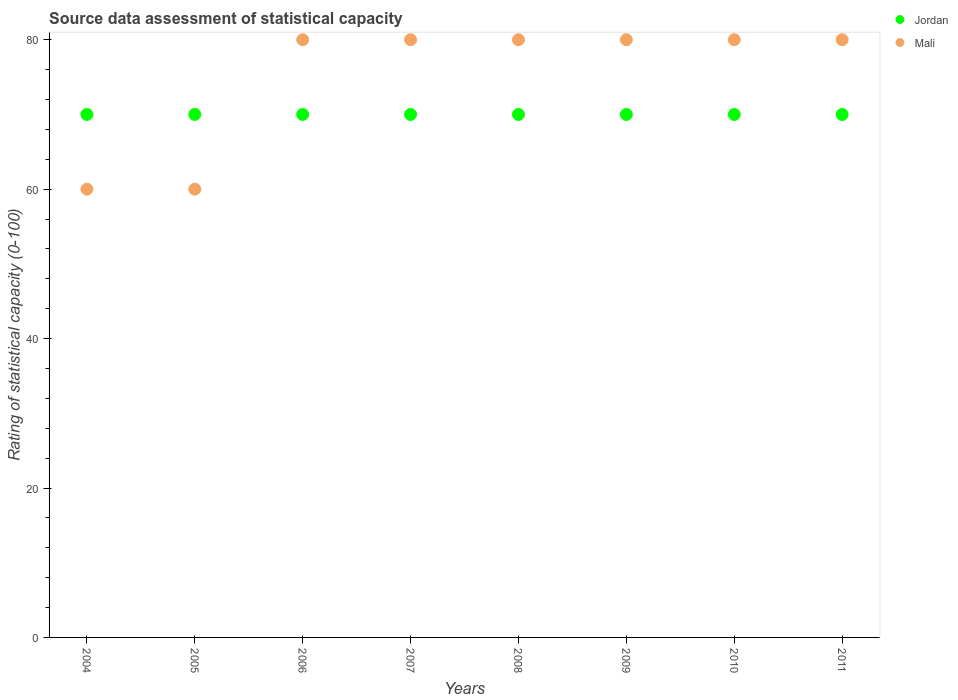What is the rating of statistical capacity in Mali in 2006?
Offer a terse response. 80. Across all years, what is the maximum rating of statistical capacity in Mali?
Your answer should be very brief. 80. Across all years, what is the minimum rating of statistical capacity in Jordan?
Make the answer very short. 70. What is the total rating of statistical capacity in Mali in the graph?
Your answer should be compact. 600. What is the difference between the rating of statistical capacity in Jordan in 2008 and the rating of statistical capacity in Mali in 2007?
Provide a short and direct response. -10. In the year 2005, what is the difference between the rating of statistical capacity in Jordan and rating of statistical capacity in Mali?
Keep it short and to the point. 10. In how many years, is the rating of statistical capacity in Jordan greater than 28?
Ensure brevity in your answer.  8. What is the ratio of the rating of statistical capacity in Jordan in 2006 to that in 2007?
Ensure brevity in your answer.  1. Is the rating of statistical capacity in Mali in 2010 less than that in 2011?
Provide a succinct answer. No. Is the difference between the rating of statistical capacity in Jordan in 2006 and 2009 greater than the difference between the rating of statistical capacity in Mali in 2006 and 2009?
Offer a very short reply. No. What is the difference between the highest and the lowest rating of statistical capacity in Mali?
Provide a short and direct response. 20. Is the sum of the rating of statistical capacity in Mali in 2007 and 2009 greater than the maximum rating of statistical capacity in Jordan across all years?
Give a very brief answer. Yes. What is the title of the graph?
Provide a short and direct response. Source data assessment of statistical capacity. What is the label or title of the Y-axis?
Give a very brief answer. Rating of statistical capacity (0-100). What is the Rating of statistical capacity (0-100) in Mali in 2004?
Offer a terse response. 60. What is the Rating of statistical capacity (0-100) in Jordan in 2006?
Your answer should be very brief. 70. What is the Rating of statistical capacity (0-100) in Mali in 2007?
Provide a short and direct response. 80. What is the Rating of statistical capacity (0-100) in Jordan in 2008?
Provide a succinct answer. 70. What is the Rating of statistical capacity (0-100) in Mali in 2008?
Keep it short and to the point. 80. What is the Rating of statistical capacity (0-100) of Mali in 2009?
Ensure brevity in your answer.  80. Across all years, what is the maximum Rating of statistical capacity (0-100) of Jordan?
Provide a short and direct response. 70. What is the total Rating of statistical capacity (0-100) of Jordan in the graph?
Provide a succinct answer. 560. What is the total Rating of statistical capacity (0-100) in Mali in the graph?
Ensure brevity in your answer.  600. What is the difference between the Rating of statistical capacity (0-100) in Jordan in 2004 and that in 2005?
Ensure brevity in your answer.  0. What is the difference between the Rating of statistical capacity (0-100) of Jordan in 2004 and that in 2006?
Provide a succinct answer. 0. What is the difference between the Rating of statistical capacity (0-100) in Mali in 2004 and that in 2007?
Provide a short and direct response. -20. What is the difference between the Rating of statistical capacity (0-100) in Jordan in 2004 and that in 2008?
Ensure brevity in your answer.  0. What is the difference between the Rating of statistical capacity (0-100) in Mali in 2004 and that in 2008?
Provide a short and direct response. -20. What is the difference between the Rating of statistical capacity (0-100) of Jordan in 2004 and that in 2011?
Make the answer very short. 0. What is the difference between the Rating of statistical capacity (0-100) of Mali in 2005 and that in 2006?
Offer a very short reply. -20. What is the difference between the Rating of statistical capacity (0-100) of Jordan in 2005 and that in 2007?
Provide a succinct answer. 0. What is the difference between the Rating of statistical capacity (0-100) in Jordan in 2005 and that in 2008?
Give a very brief answer. 0. What is the difference between the Rating of statistical capacity (0-100) in Mali in 2005 and that in 2008?
Your answer should be compact. -20. What is the difference between the Rating of statistical capacity (0-100) of Jordan in 2005 and that in 2009?
Give a very brief answer. 0. What is the difference between the Rating of statistical capacity (0-100) in Mali in 2005 and that in 2009?
Make the answer very short. -20. What is the difference between the Rating of statistical capacity (0-100) of Jordan in 2005 and that in 2010?
Your answer should be compact. 0. What is the difference between the Rating of statistical capacity (0-100) in Jordan in 2005 and that in 2011?
Your answer should be very brief. 0. What is the difference between the Rating of statistical capacity (0-100) of Jordan in 2006 and that in 2007?
Provide a short and direct response. 0. What is the difference between the Rating of statistical capacity (0-100) in Mali in 2006 and that in 2007?
Provide a succinct answer. 0. What is the difference between the Rating of statistical capacity (0-100) of Mali in 2006 and that in 2008?
Keep it short and to the point. 0. What is the difference between the Rating of statistical capacity (0-100) of Jordan in 2006 and that in 2009?
Keep it short and to the point. 0. What is the difference between the Rating of statistical capacity (0-100) in Mali in 2006 and that in 2009?
Make the answer very short. 0. What is the difference between the Rating of statistical capacity (0-100) of Jordan in 2006 and that in 2010?
Provide a short and direct response. 0. What is the difference between the Rating of statistical capacity (0-100) of Mali in 2006 and that in 2010?
Ensure brevity in your answer.  0. What is the difference between the Rating of statistical capacity (0-100) in Mali in 2006 and that in 2011?
Offer a very short reply. 0. What is the difference between the Rating of statistical capacity (0-100) in Jordan in 2007 and that in 2008?
Keep it short and to the point. 0. What is the difference between the Rating of statistical capacity (0-100) of Jordan in 2007 and that in 2009?
Your response must be concise. 0. What is the difference between the Rating of statistical capacity (0-100) of Mali in 2007 and that in 2009?
Offer a very short reply. 0. What is the difference between the Rating of statistical capacity (0-100) of Jordan in 2007 and that in 2010?
Your answer should be compact. 0. What is the difference between the Rating of statistical capacity (0-100) of Mali in 2007 and that in 2010?
Offer a terse response. 0. What is the difference between the Rating of statistical capacity (0-100) of Mali in 2007 and that in 2011?
Make the answer very short. 0. What is the difference between the Rating of statistical capacity (0-100) in Jordan in 2008 and that in 2010?
Ensure brevity in your answer.  0. What is the difference between the Rating of statistical capacity (0-100) in Mali in 2008 and that in 2010?
Keep it short and to the point. 0. What is the difference between the Rating of statistical capacity (0-100) of Mali in 2009 and that in 2010?
Provide a succinct answer. 0. What is the difference between the Rating of statistical capacity (0-100) in Mali in 2009 and that in 2011?
Your answer should be very brief. 0. What is the difference between the Rating of statistical capacity (0-100) in Jordan in 2004 and the Rating of statistical capacity (0-100) in Mali in 2005?
Keep it short and to the point. 10. What is the difference between the Rating of statistical capacity (0-100) in Jordan in 2004 and the Rating of statistical capacity (0-100) in Mali in 2007?
Provide a short and direct response. -10. What is the difference between the Rating of statistical capacity (0-100) of Jordan in 2004 and the Rating of statistical capacity (0-100) of Mali in 2008?
Your answer should be very brief. -10. What is the difference between the Rating of statistical capacity (0-100) in Jordan in 2004 and the Rating of statistical capacity (0-100) in Mali in 2009?
Your answer should be very brief. -10. What is the difference between the Rating of statistical capacity (0-100) in Jordan in 2004 and the Rating of statistical capacity (0-100) in Mali in 2010?
Give a very brief answer. -10. What is the difference between the Rating of statistical capacity (0-100) in Jordan in 2004 and the Rating of statistical capacity (0-100) in Mali in 2011?
Your answer should be compact. -10. What is the difference between the Rating of statistical capacity (0-100) of Jordan in 2005 and the Rating of statistical capacity (0-100) of Mali in 2006?
Offer a very short reply. -10. What is the difference between the Rating of statistical capacity (0-100) of Jordan in 2005 and the Rating of statistical capacity (0-100) of Mali in 2008?
Your answer should be compact. -10. What is the difference between the Rating of statistical capacity (0-100) in Jordan in 2005 and the Rating of statistical capacity (0-100) in Mali in 2009?
Offer a terse response. -10. What is the difference between the Rating of statistical capacity (0-100) of Jordan in 2005 and the Rating of statistical capacity (0-100) of Mali in 2011?
Ensure brevity in your answer.  -10. What is the difference between the Rating of statistical capacity (0-100) of Jordan in 2006 and the Rating of statistical capacity (0-100) of Mali in 2008?
Keep it short and to the point. -10. What is the difference between the Rating of statistical capacity (0-100) in Jordan in 2006 and the Rating of statistical capacity (0-100) in Mali in 2010?
Make the answer very short. -10. What is the difference between the Rating of statistical capacity (0-100) in Jordan in 2007 and the Rating of statistical capacity (0-100) in Mali in 2008?
Ensure brevity in your answer.  -10. What is the difference between the Rating of statistical capacity (0-100) of Jordan in 2007 and the Rating of statistical capacity (0-100) of Mali in 2009?
Make the answer very short. -10. What is the difference between the Rating of statistical capacity (0-100) of Jordan in 2007 and the Rating of statistical capacity (0-100) of Mali in 2010?
Provide a succinct answer. -10. What is the difference between the Rating of statistical capacity (0-100) of Jordan in 2008 and the Rating of statistical capacity (0-100) of Mali in 2009?
Provide a succinct answer. -10. What is the difference between the Rating of statistical capacity (0-100) of Jordan in 2008 and the Rating of statistical capacity (0-100) of Mali in 2010?
Keep it short and to the point. -10. What is the difference between the Rating of statistical capacity (0-100) in Jordan in 2008 and the Rating of statistical capacity (0-100) in Mali in 2011?
Give a very brief answer. -10. What is the difference between the Rating of statistical capacity (0-100) of Jordan in 2009 and the Rating of statistical capacity (0-100) of Mali in 2010?
Offer a terse response. -10. What is the difference between the Rating of statistical capacity (0-100) in Jordan in 2009 and the Rating of statistical capacity (0-100) in Mali in 2011?
Offer a terse response. -10. What is the average Rating of statistical capacity (0-100) of Mali per year?
Offer a very short reply. 75. In the year 2006, what is the difference between the Rating of statistical capacity (0-100) in Jordan and Rating of statistical capacity (0-100) in Mali?
Make the answer very short. -10. In the year 2007, what is the difference between the Rating of statistical capacity (0-100) in Jordan and Rating of statistical capacity (0-100) in Mali?
Ensure brevity in your answer.  -10. In the year 2008, what is the difference between the Rating of statistical capacity (0-100) of Jordan and Rating of statistical capacity (0-100) of Mali?
Your answer should be compact. -10. In the year 2011, what is the difference between the Rating of statistical capacity (0-100) in Jordan and Rating of statistical capacity (0-100) in Mali?
Give a very brief answer. -10. What is the ratio of the Rating of statistical capacity (0-100) of Jordan in 2004 to that in 2005?
Provide a short and direct response. 1. What is the ratio of the Rating of statistical capacity (0-100) in Jordan in 2004 to that in 2006?
Keep it short and to the point. 1. What is the ratio of the Rating of statistical capacity (0-100) in Jordan in 2004 to that in 2007?
Offer a very short reply. 1. What is the ratio of the Rating of statistical capacity (0-100) in Mali in 2004 to that in 2007?
Give a very brief answer. 0.75. What is the ratio of the Rating of statistical capacity (0-100) of Jordan in 2004 to that in 2008?
Your response must be concise. 1. What is the ratio of the Rating of statistical capacity (0-100) of Jordan in 2004 to that in 2010?
Your answer should be compact. 1. What is the ratio of the Rating of statistical capacity (0-100) in Mali in 2004 to that in 2011?
Your response must be concise. 0.75. What is the ratio of the Rating of statistical capacity (0-100) in Jordan in 2005 to that in 2006?
Provide a succinct answer. 1. What is the ratio of the Rating of statistical capacity (0-100) in Mali in 2005 to that in 2007?
Give a very brief answer. 0.75. What is the ratio of the Rating of statistical capacity (0-100) in Jordan in 2005 to that in 2008?
Give a very brief answer. 1. What is the ratio of the Rating of statistical capacity (0-100) in Mali in 2005 to that in 2008?
Give a very brief answer. 0.75. What is the ratio of the Rating of statistical capacity (0-100) in Jordan in 2005 to that in 2009?
Offer a very short reply. 1. What is the ratio of the Rating of statistical capacity (0-100) in Mali in 2005 to that in 2009?
Give a very brief answer. 0.75. What is the ratio of the Rating of statistical capacity (0-100) in Jordan in 2005 to that in 2010?
Give a very brief answer. 1. What is the ratio of the Rating of statistical capacity (0-100) of Jordan in 2005 to that in 2011?
Give a very brief answer. 1. What is the ratio of the Rating of statistical capacity (0-100) of Jordan in 2006 to that in 2007?
Your answer should be very brief. 1. What is the ratio of the Rating of statistical capacity (0-100) of Mali in 2006 to that in 2007?
Make the answer very short. 1. What is the ratio of the Rating of statistical capacity (0-100) in Jordan in 2006 to that in 2008?
Provide a short and direct response. 1. What is the ratio of the Rating of statistical capacity (0-100) in Jordan in 2006 to that in 2009?
Offer a very short reply. 1. What is the ratio of the Rating of statistical capacity (0-100) of Mali in 2007 to that in 2008?
Provide a short and direct response. 1. What is the ratio of the Rating of statistical capacity (0-100) in Jordan in 2007 to that in 2009?
Provide a succinct answer. 1. What is the ratio of the Rating of statistical capacity (0-100) of Mali in 2007 to that in 2009?
Your answer should be compact. 1. What is the ratio of the Rating of statistical capacity (0-100) of Jordan in 2007 to that in 2010?
Your response must be concise. 1. What is the ratio of the Rating of statistical capacity (0-100) in Jordan in 2008 to that in 2009?
Provide a succinct answer. 1. What is the ratio of the Rating of statistical capacity (0-100) of Mali in 2008 to that in 2009?
Make the answer very short. 1. What is the ratio of the Rating of statistical capacity (0-100) of Mali in 2008 to that in 2011?
Give a very brief answer. 1. What is the ratio of the Rating of statistical capacity (0-100) in Jordan in 2009 to that in 2011?
Your answer should be compact. 1. What is the ratio of the Rating of statistical capacity (0-100) in Mali in 2009 to that in 2011?
Make the answer very short. 1. What is the difference between the highest and the second highest Rating of statistical capacity (0-100) of Jordan?
Give a very brief answer. 0. 